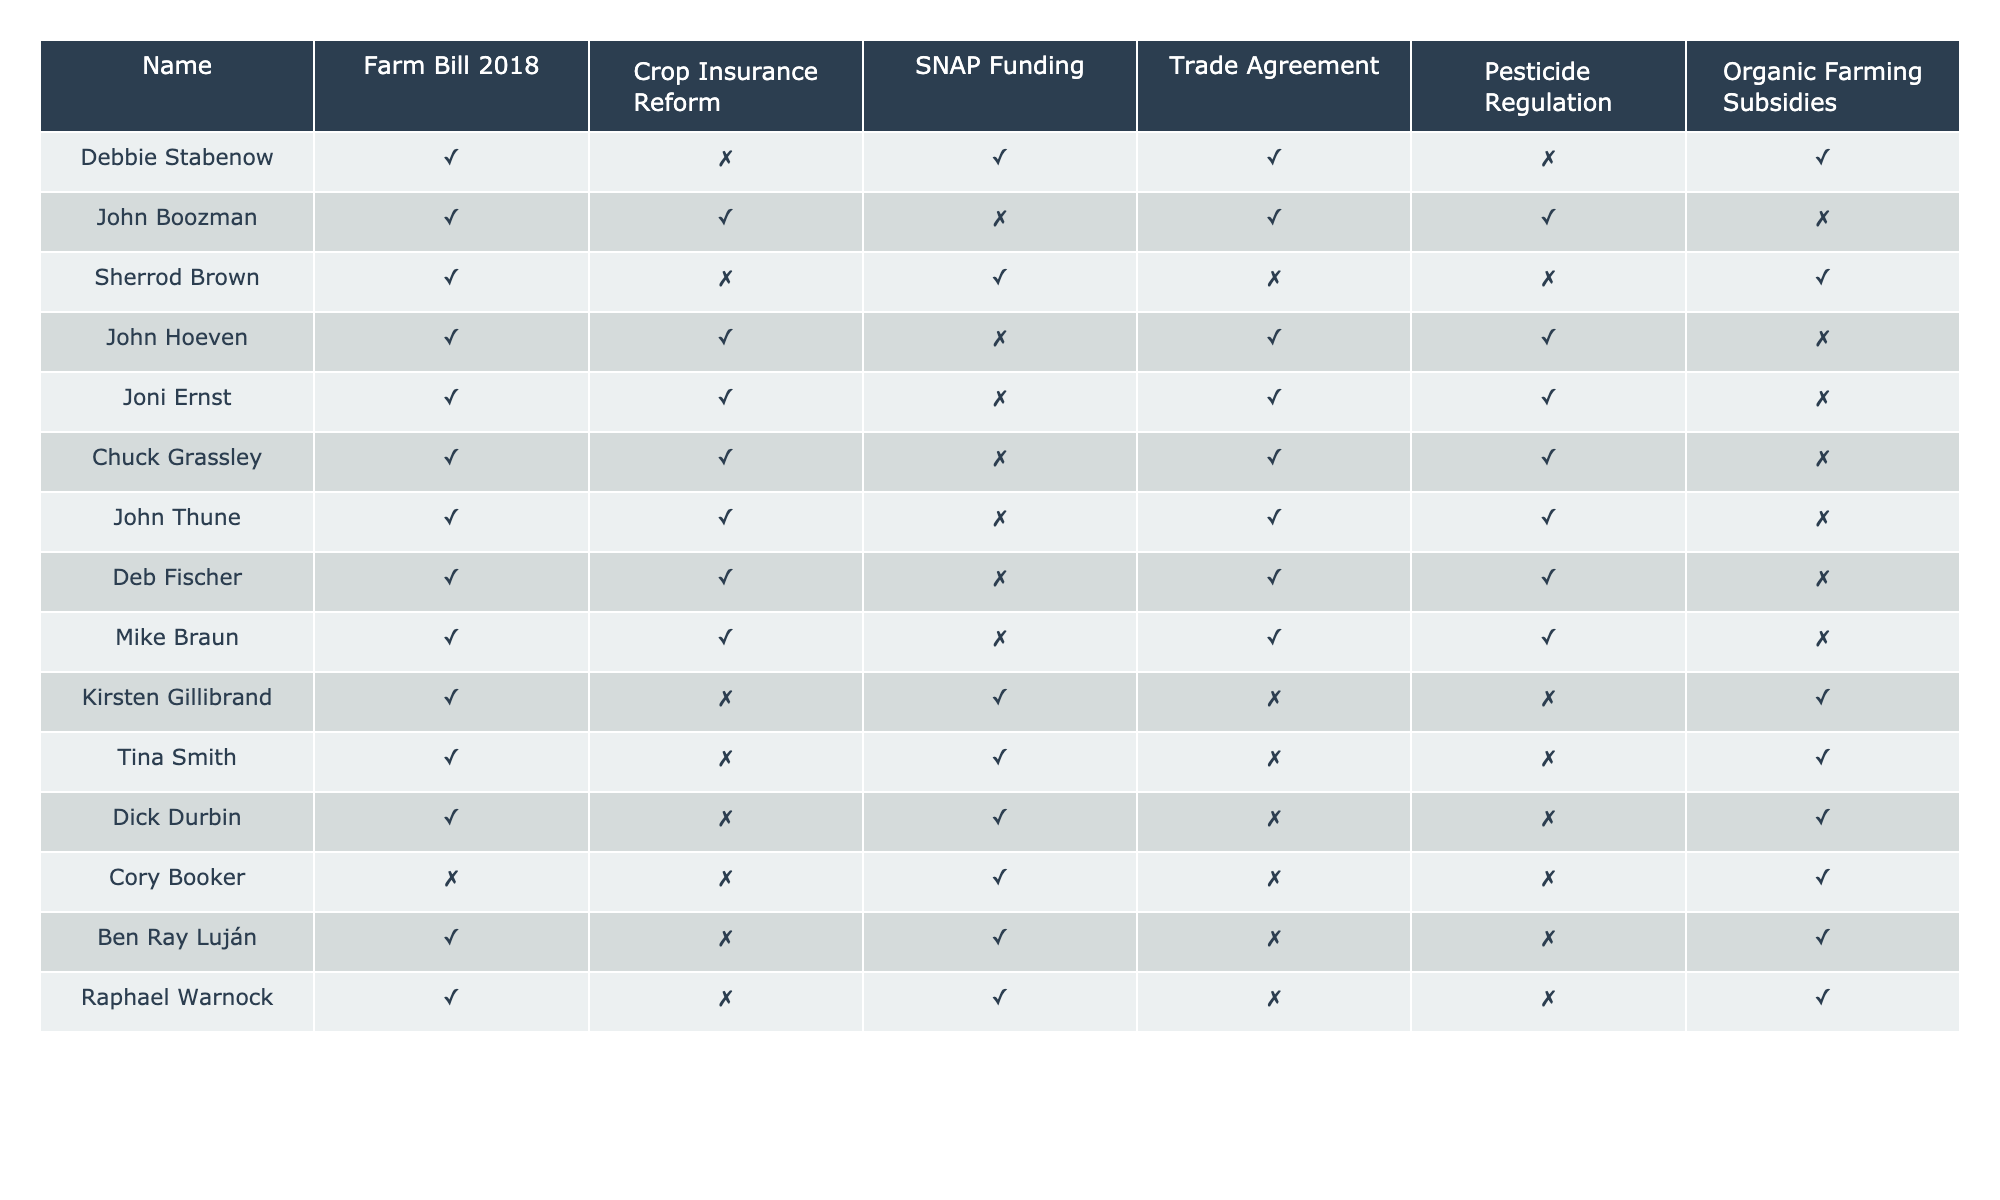What is the voting record of Debbie Stabenow on Crop Insurance Reform? Debbie Stabenow's voting record on Crop Insurance Reform is shown in the table, where the value is 0, indicating she did not support this policy.
Answer: No How many committee members voted in favor of Pesticide Regulation? By reviewing the table, we see that 6 committee members voted '✓' for Pesticide Regulation.
Answer: 6 Which member voted against SNAP Funding? In the table, both John Boozman and Cory Booker show a vote of 0 for SNAP Funding, meaning they opposed it.
Answer: John Boozman and Cory Booker Did any committee members vote 'yes' for Organic Farming Subsidies? To find this, we check the table for any members with a vote of 1 for Organic Farming Subsidies. The entries show that a few members did indeed vote '✓', confirming support for this subsidy.
Answer: Yes Which policy had the highest number of 'no' votes? To determine this, we count the '✗' votes for each policy. The analysis shows that Crop Insurance Reform has the highest number of '✗' votes.
Answer: Crop Insurance Reform How many members supported both the Farm Bill 2018 and Trade Agreement? We need to identify committee members who voted '✓' for both the Farm Bill 2018 and Trade Agreement by going through the table. A total of 7 members meet this criterion.
Answer: 7 Is there any member who supported all policies? By examining each member's votes in the table, we can see that no members voted '✓' for all the agricultural policies listed, as all voted against at least one policy.
Answer: No Which member has the most split opinions across the policies? To assess this, we look for the member with the greatest disparity in '✓' and '✗' votes. Cory Booker has votes that reflect a more negative stance on all except for SNAP and Organic Farming.
Answer: Cory Booker How many members voted in favor of both the Farm Bill 2018 and Crop Insurance Reform? Review members who voted '✓' for both policies, which leads to a count of 8 committee members who supported both policies.
Answer: 8 What is the total number of policies supported by Joni Ernst? By summing the number of '✓' votes for Joni Ernst in the table, we find she supported 4 policies.
Answer: 4 